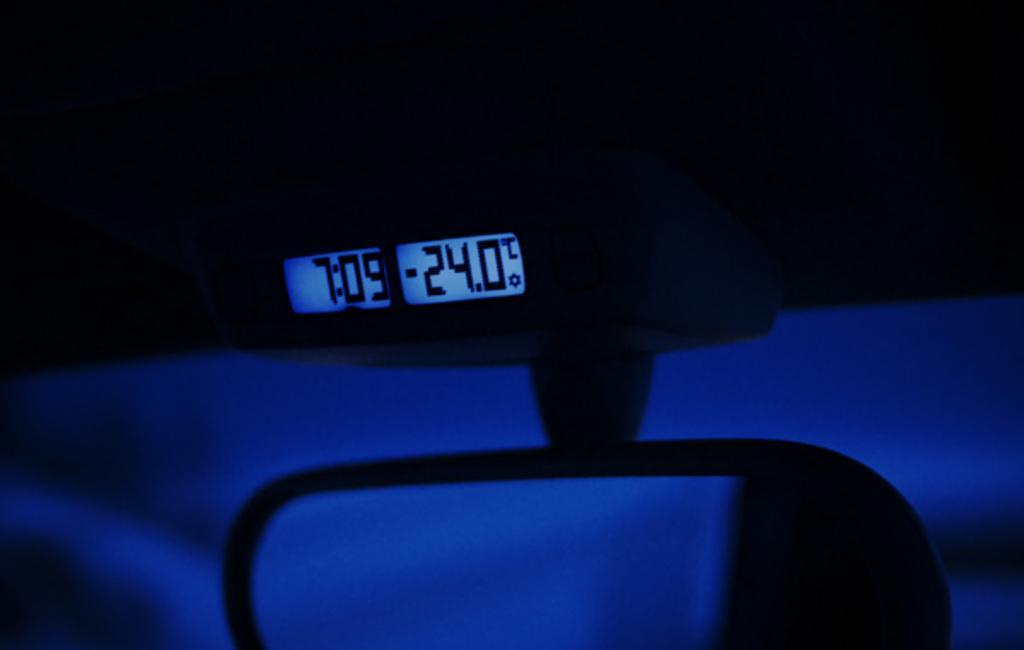In one or two sentences, can you explain what this image depicts? In this image I can see the led display and I can see the black and blue color object. 